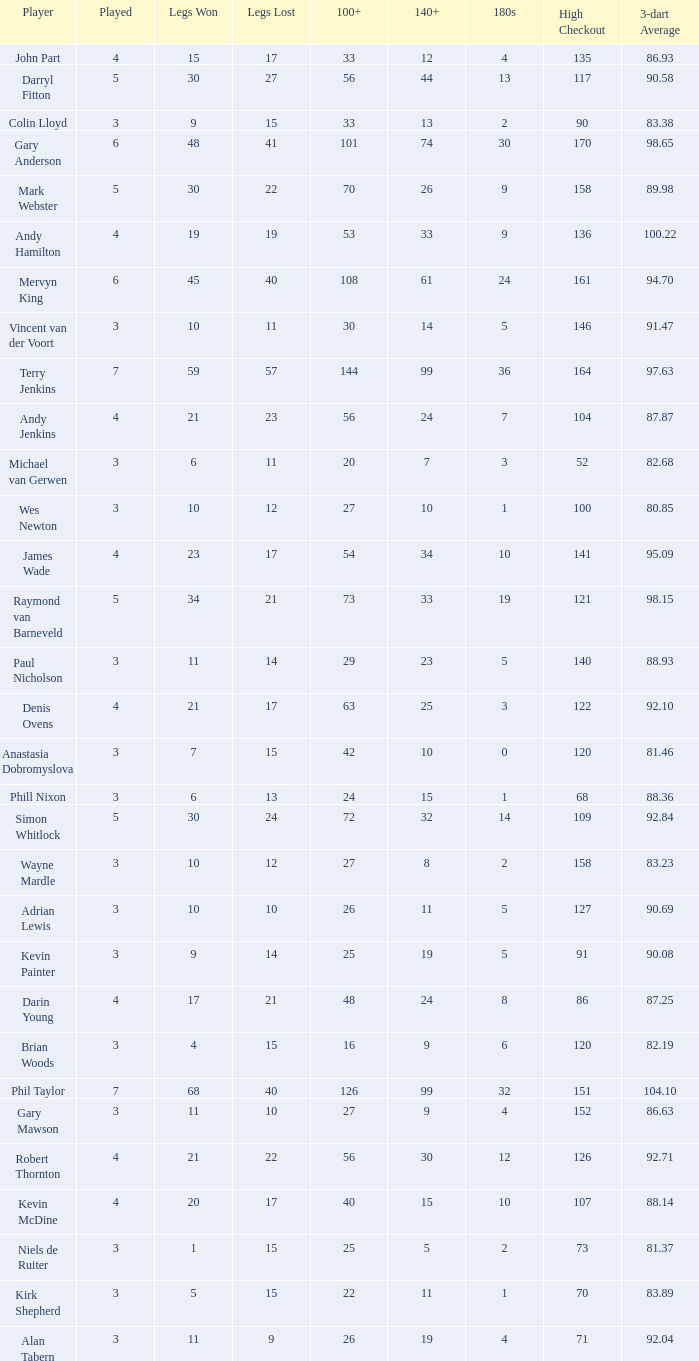Who is the player with 41 legs lost? Gary Anderson. 